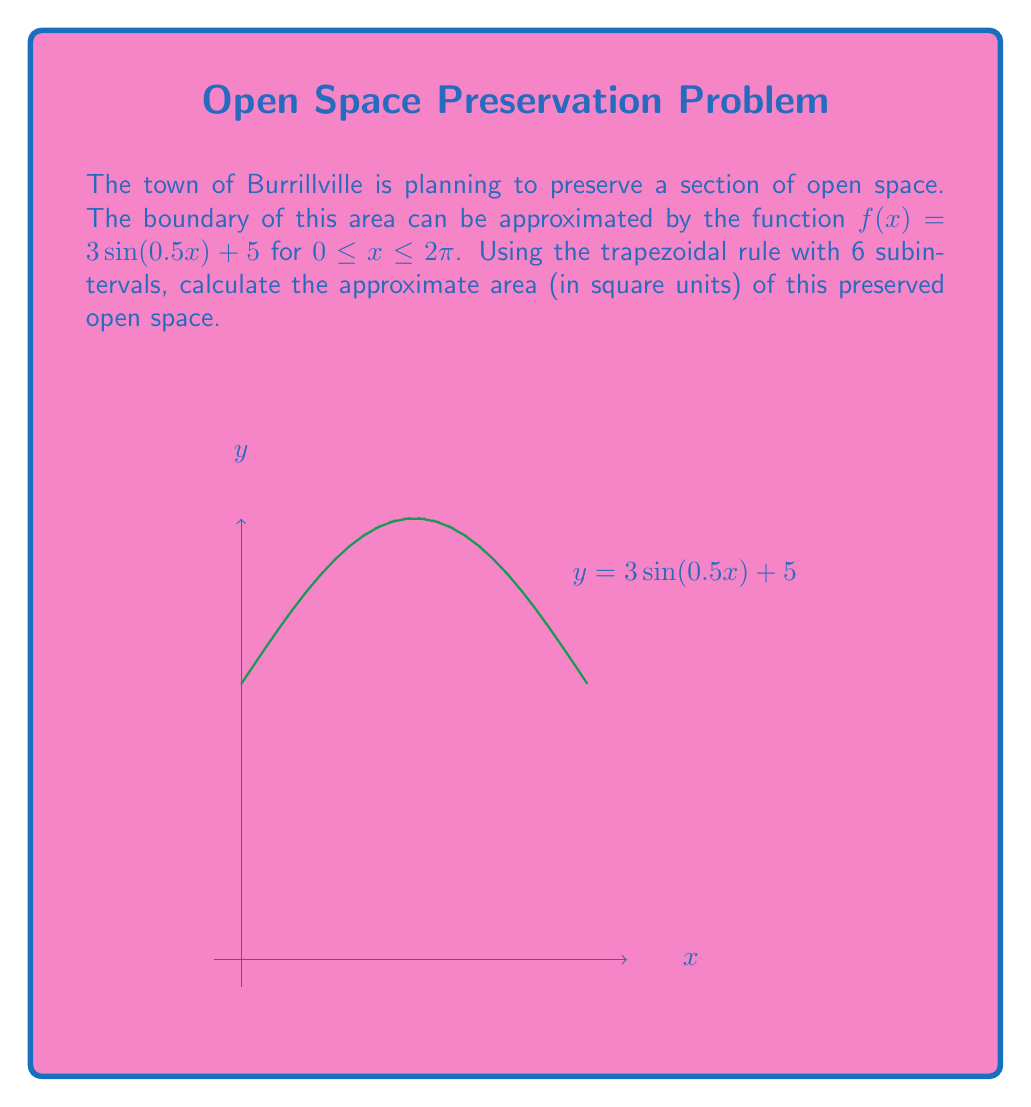Provide a solution to this math problem. To solve this problem using the trapezoidal rule, we'll follow these steps:

1) The trapezoidal rule formula for n subintervals is:

   $$\int_{a}^{b} f(x) dx \approx \frac{b-a}{2n}\left[f(a) + 2\sum_{i=1}^{n-1}f(x_i) + f(b)\right]$$

2) Here, $a = 0$, $b = 2\pi$, $n = 6$, and $f(x) = 3\sin(0.5x) + 5$

3) Calculate the width of each subinterval:
   $$\Delta x = \frac{b-a}{n} = \frac{2\pi - 0}{6} = \frac{\pi}{3}$$

4) Calculate $x_i$ values:
   $x_0 = 0$
   $x_1 = \frac{\pi}{3}$
   $x_2 = \frac{2\pi}{3}$
   $x_3 = \pi$
   $x_4 = \frac{4\pi}{3}$
   $x_5 = \frac{5\pi}{3}$
   $x_6 = 2\pi$

5) Calculate $f(x_i)$ values:
   $f(x_0) = 3\sin(0) + 5 = 5$
   $f(x_1) = 3\sin(\frac{\pi}{6}) + 5 \approx 6.5$
   $f(x_2) = 3\sin(\frac{\pi}{3}) + 5 \approx 7.598$
   $f(x_3) = 3\sin(\frac{\pi}{2}) + 5 = 8$
   $f(x_4) = 3\sin(\frac{2\pi}{3}) + 5 \approx 7.598$
   $f(x_5) = 3\sin(\frac{5\pi}{6}) + 5 \approx 6.5$
   $f(x_6) = 3\sin(\pi) + 5 = 5$

6) Apply the trapezoidal rule:
   $$\text{Area} \approx \frac{\pi}{3}\left[5 + 2(6.5 + 7.598 + 8 + 7.598 + 6.5) + 5\right]$$
   $$\approx \frac{\pi}{3}(5 + 72.392 + 5)$$
   $$\approx \frac{\pi}{3}(82.392)$$
   $$\approx 86.33 \text{ square units}$$
Answer: 86.33 square units 